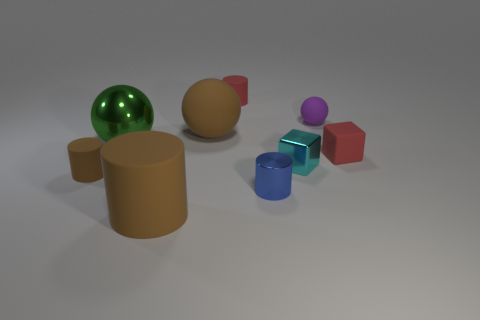What types of materials do the objects in the image look like they could be made of? The objects in the image exhibit various textures and sheens that suggest they could be made of a range of materials. The green sphere looks like it could be made of glass due to its reflective and transparent qualities. The brown and beige objects might be made of a matte substance such as ceramic or unglazed clay, while the metallic sheen on the blue and red cubes and the purple sphere hint at a metal or plastic material with a reflective coating. 